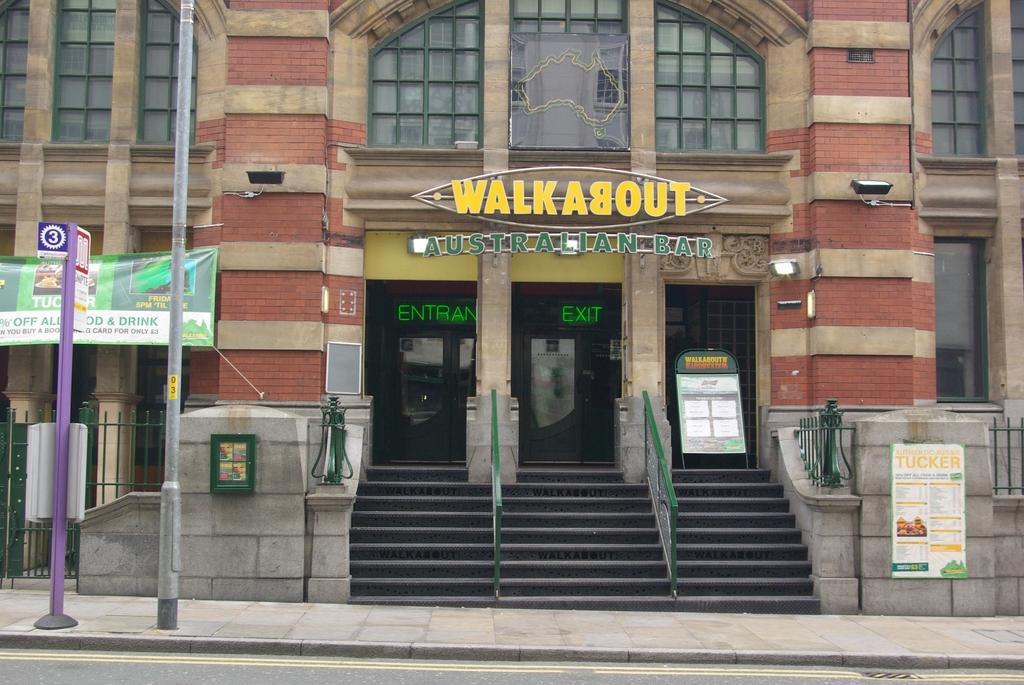Can you describe this image briefly? In this image we can see a building, road, there are some poles, boards, there are some stairs and fencing. 